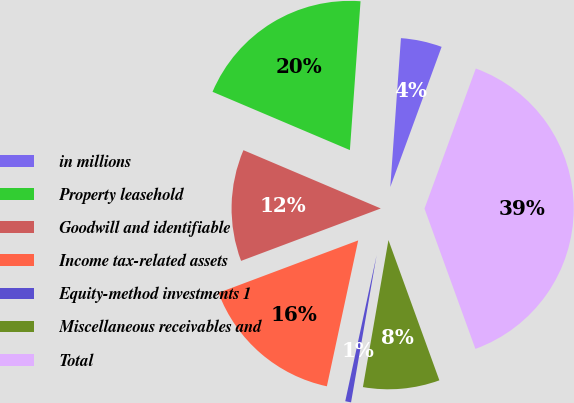Convert chart to OTSL. <chart><loc_0><loc_0><loc_500><loc_500><pie_chart><fcel>in millions<fcel>Property leasehold<fcel>Goodwill and identifiable<fcel>Income tax-related assets<fcel>Equity-method investments 1<fcel>Miscellaneous receivables and<fcel>Total<nl><fcel>4.45%<fcel>19.75%<fcel>12.1%<fcel>15.92%<fcel>0.63%<fcel>8.28%<fcel>38.87%<nl></chart> 